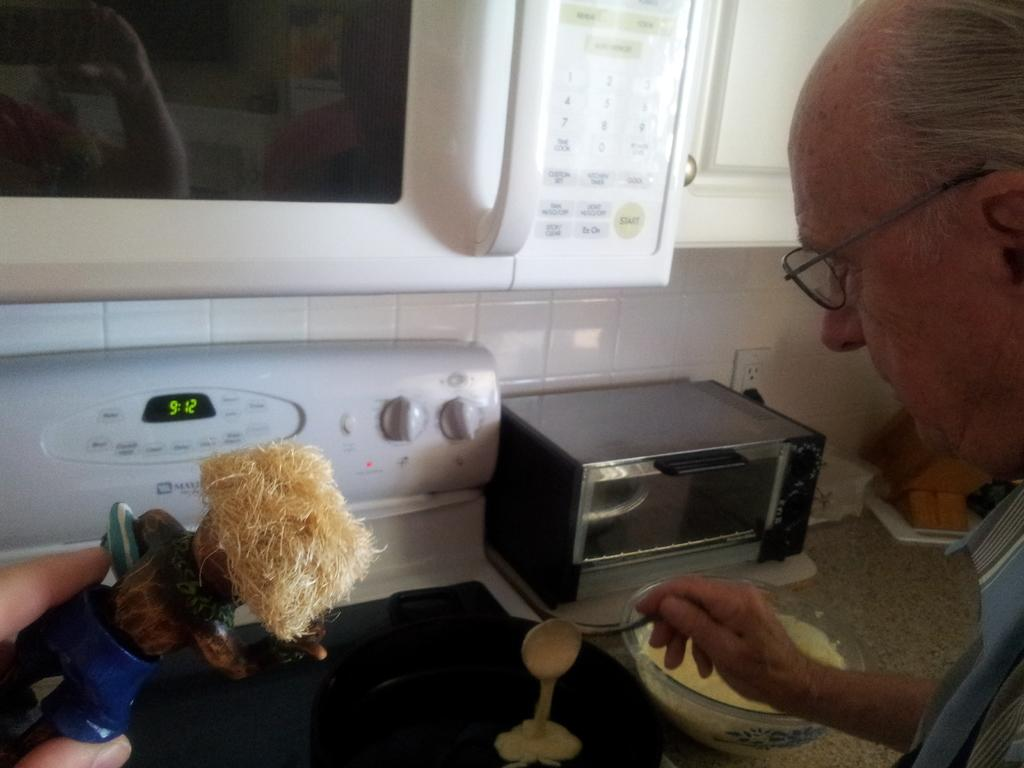<image>
Provide a brief description of the given image. Pancakes are hitting the pan on the stove at 9:12. 